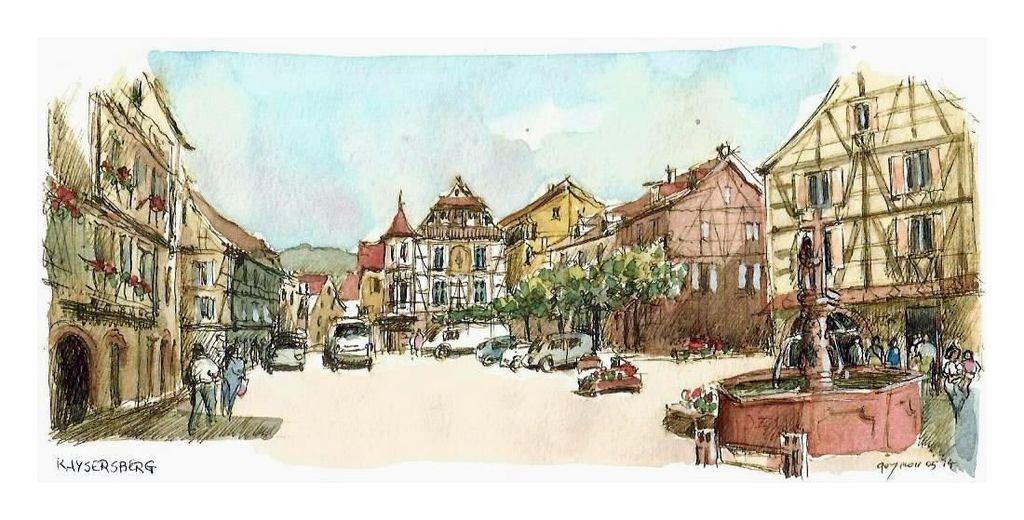How would you summarize this image in a sentence or two? In this aimeg, we can see a painting. Here we can see buildings, trees, water fountains, few people, some objects and vehicles. Here there is the sky. At the bottom of the image, we can see some text. 